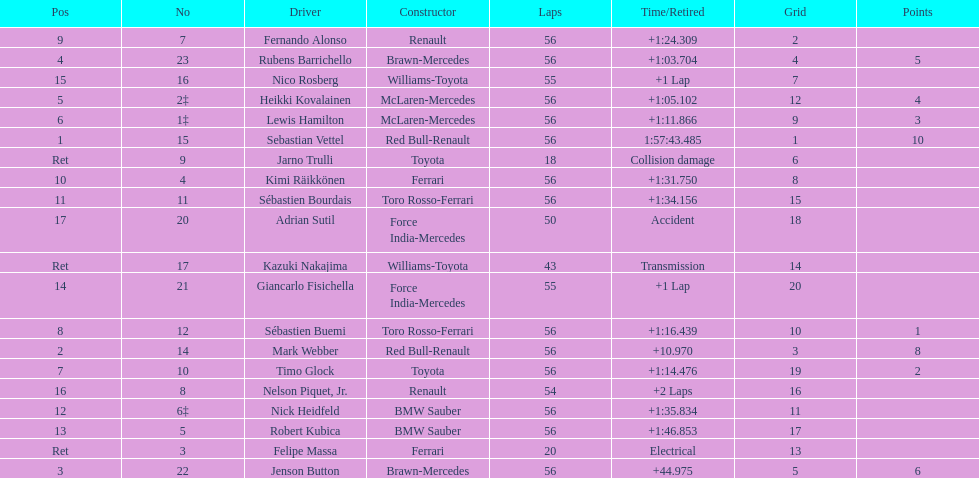Who was the slowest driver to finish the race? Robert Kubica. 